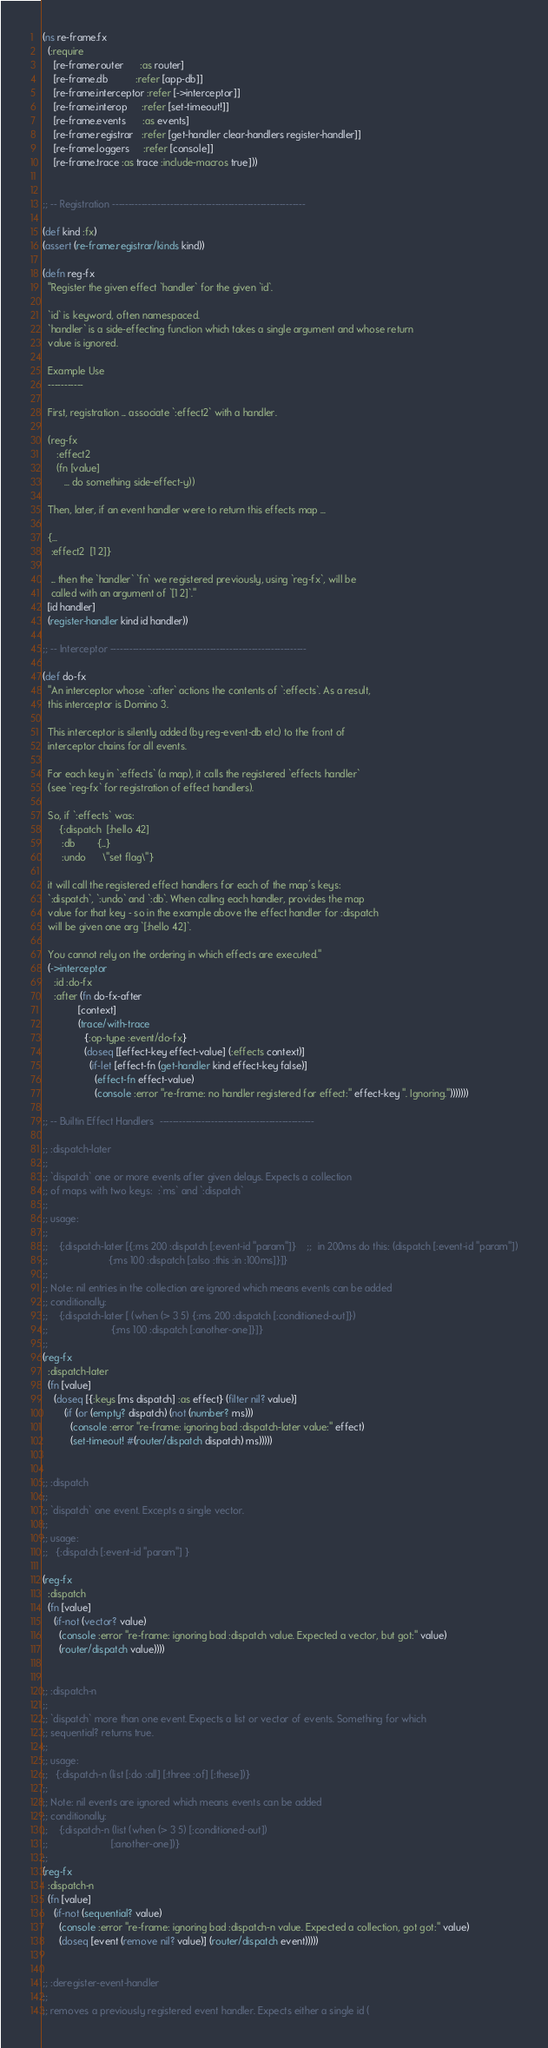<code> <loc_0><loc_0><loc_500><loc_500><_Clojure_>(ns re-frame.fx
  (:require
    [re-frame.router      :as router]
    [re-frame.db          :refer [app-db]]
    [re-frame.interceptor :refer [->interceptor]]
    [re-frame.interop     :refer [set-timeout!]]
    [re-frame.events      :as events]
    [re-frame.registrar   :refer [get-handler clear-handlers register-handler]]
    [re-frame.loggers     :refer [console]]
    [re-frame.trace :as trace :include-macros true]))


;; -- Registration ------------------------------------------------------------

(def kind :fx)
(assert (re-frame.registrar/kinds kind))

(defn reg-fx
  "Register the given effect `handler` for the given `id`.

  `id` is keyword, often namespaced.
  `handler` is a side-effecting function which takes a single argument and whose return
  value is ignored.

  Example Use
  -----------

  First, registration ... associate `:effect2` with a handler.

  (reg-fx
     :effect2
     (fn [value]
        ... do something side-effect-y))

  Then, later, if an event handler were to return this effects map ...

  {...
   :effect2  [1 2]}

   ... then the `handler` `fn` we registered previously, using `reg-fx`, will be
   called with an argument of `[1 2]`."
  [id handler]
  (register-handler kind id handler))

;; -- Interceptor -------------------------------------------------------------

(def do-fx
  "An interceptor whose `:after` actions the contents of `:effects`. As a result,
  this interceptor is Domino 3.

  This interceptor is silently added (by reg-event-db etc) to the front of
  interceptor chains for all events.

  For each key in `:effects` (a map), it calls the registered `effects handler`
  (see `reg-fx` for registration of effect handlers).

  So, if `:effects` was:
      {:dispatch  [:hello 42]
       :db        {...}
       :undo      \"set flag\"}

  it will call the registered effect handlers for each of the map's keys:
  `:dispatch`, `:undo` and `:db`. When calling each handler, provides the map
  value for that key - so in the example above the effect handler for :dispatch
  will be given one arg `[:hello 42]`.

  You cannot rely on the ordering in which effects are executed."
  (->interceptor
    :id :do-fx
    :after (fn do-fx-after
             [context]
             (trace/with-trace
               {:op-type :event/do-fx}
               (doseq [[effect-key effect-value] (:effects context)]
                 (if-let [effect-fn (get-handler kind effect-key false)]
                   (effect-fn effect-value)
                   (console :error "re-frame: no handler registered for effect:" effect-key ". Ignoring.")))))))

;; -- Builtin Effect Handlers  ------------------------------------------------

;; :dispatch-later
;;
;; `dispatch` one or more events after given delays. Expects a collection
;; of maps with two keys:  :`ms` and `:dispatch`
;;
;; usage:
;;
;;    {:dispatch-later [{:ms 200 :dispatch [:event-id "param"]}    ;;  in 200ms do this: (dispatch [:event-id "param"])
;;                      {:ms 100 :dispatch [:also :this :in :100ms]}]}
;;
;; Note: nil entries in the collection are ignored which means events can be added
;; conditionally:
;;    {:dispatch-later [ (when (> 3 5) {:ms 200 :dispatch [:conditioned-out]})
;;                       {:ms 100 :dispatch [:another-one]}]}
;;
(reg-fx
  :dispatch-later
  (fn [value]
    (doseq [{:keys [ms dispatch] :as effect} (filter nil? value)]
        (if (or (empty? dispatch) (not (number? ms)))
          (console :error "re-frame: ignoring bad :dispatch-later value:" effect)
          (set-timeout! #(router/dispatch dispatch) ms)))))


;; :dispatch
;;
;; `dispatch` one event. Excepts a single vector.
;;
;; usage:
;;   {:dispatch [:event-id "param"] }

(reg-fx
  :dispatch
  (fn [value]
    (if-not (vector? value)
      (console :error "re-frame: ignoring bad :dispatch value. Expected a vector, but got:" value)
      (router/dispatch value))))


;; :dispatch-n
;;
;; `dispatch` more than one event. Expects a list or vector of events. Something for which
;; sequential? returns true.
;;
;; usage:
;;   {:dispatch-n (list [:do :all] [:three :of] [:these])}
;;
;; Note: nil events are ignored which means events can be added
;; conditionally:
;;    {:dispatch-n (list (when (> 3 5) [:conditioned-out])
;;                       [:another-one])}
;;
(reg-fx
  :dispatch-n
  (fn [value]
    (if-not (sequential? value)
      (console :error "re-frame: ignoring bad :dispatch-n value. Expected a collection, got got:" value)
      (doseq [event (remove nil? value)] (router/dispatch event)))))


;; :deregister-event-handler
;;
;; removes a previously registered event handler. Expects either a single id (</code> 